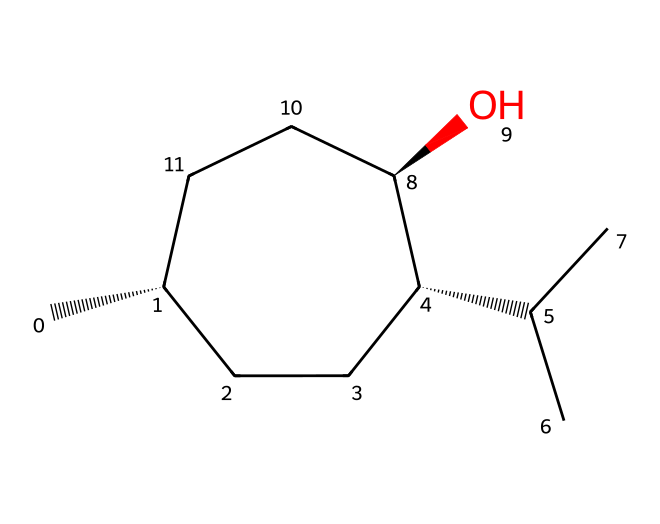What is the common name of the compound represented by the SMILES? The structure corresponds to menthol, which is a known cyclic monoterpene alcohol. It's specifically noted for its use in throat lozenges and its cooling effect.
Answer: menthol How many chiral centers are present in the compound? By examining the structure, there are three carbon atoms bonded to four different substituents, indicating the presence of three chiral centers.
Answer: three What type of stereoisomers does this compound exhibit? The presence of chiral centers allows for configurations such as enantiomers and possibly diastereomers; however, due to specific geometric orientations, mainly enantiomers are accounted here.
Answer: enantiomers What functional group is present in menthol that contributes to its health benefits? The hydroxyl (–OH) group present in the structure is a vital functional group associated with the cooling properties and health benefits, as it allows interaction with receptors in the throat.
Answer: hydroxyl Can this compound exist in geometric isomers? Given that there are multiple groups around the chiral centers and certain double bonds may create distinct spatial arrangements, geometric isomers can be formed, but with a focus on the orientation since it is a saturated ring structure.
Answer: yes What is the total number of carbon atoms in the compound? By counting the carbon atoms in the structure, we find that there are ten carbon atoms linked in the structure, which contributes to its complex nature.
Answer: ten 